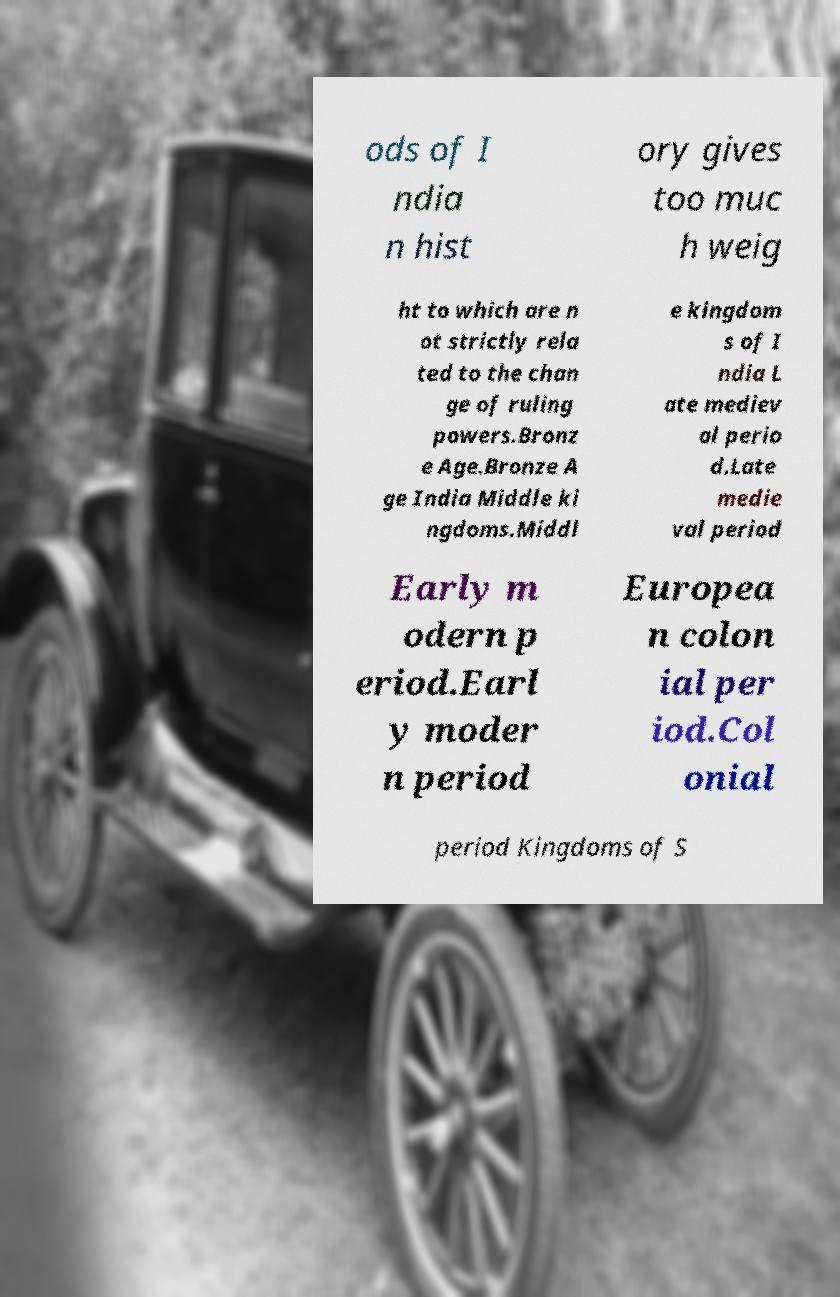What messages or text are displayed in this image? I need them in a readable, typed format. ods of I ndia n hist ory gives too muc h weig ht to which are n ot strictly rela ted to the chan ge of ruling powers.Bronz e Age.Bronze A ge India Middle ki ngdoms.Middl e kingdom s of I ndia L ate mediev al perio d.Late medie val period Early m odern p eriod.Earl y moder n period Europea n colon ial per iod.Col onial period Kingdoms of S 